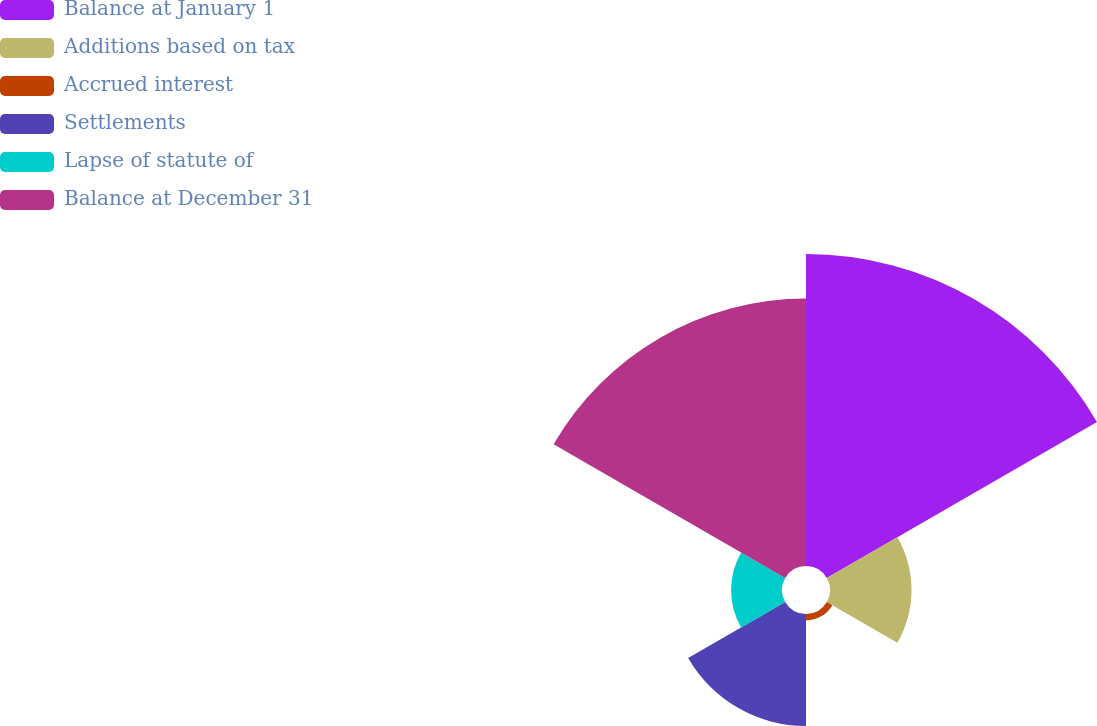Convert chart to OTSL. <chart><loc_0><loc_0><loc_500><loc_500><pie_chart><fcel>Balance at January 1<fcel>Additions based on tax<fcel>Accrued interest<fcel>Settlements<fcel>Lapse of statute of<fcel>Balance at December 31<nl><fcel>37.58%<fcel>9.82%<fcel>0.77%<fcel>13.5%<fcel>6.13%<fcel>32.21%<nl></chart> 